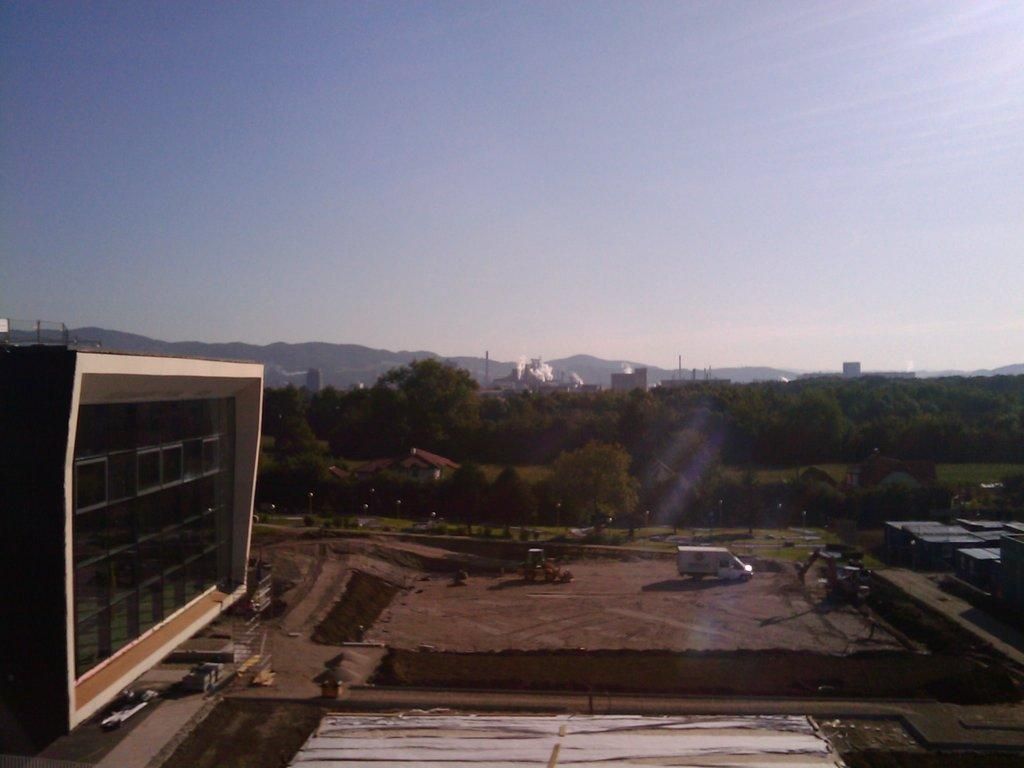What type of structure is present in the image? There is a building in the image. What natural elements can be seen in the image? There are trees and mountains in the image. What man-made objects are visible in the image? There are vehicles in the image. What part of the natural environment is visible in the background of the image? The sky is visible in the background of the image. What type of wool is being used by the group in the image? There is no group or wool present in the image. How does the love between the people in the image manifest itself? There are no people or love depicted in the image; it features a building, trees, mountains, vehicles, and the sky. 